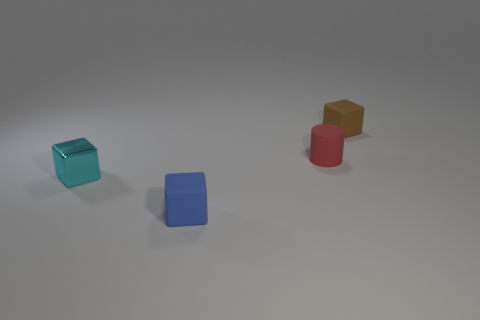Subtract all tiny matte cubes. How many cubes are left? 1 Subtract all blue blocks. How many blocks are left? 2 Subtract all green spheres. How many brown cylinders are left? 0 Add 2 small brown matte things. How many objects exist? 6 Subtract 0 red balls. How many objects are left? 4 Subtract all cylinders. How many objects are left? 3 Subtract 1 cylinders. How many cylinders are left? 0 Subtract all cyan blocks. Subtract all brown spheres. How many blocks are left? 2 Subtract all tiny blue rubber cubes. Subtract all red objects. How many objects are left? 2 Add 1 tiny matte cylinders. How many tiny matte cylinders are left? 2 